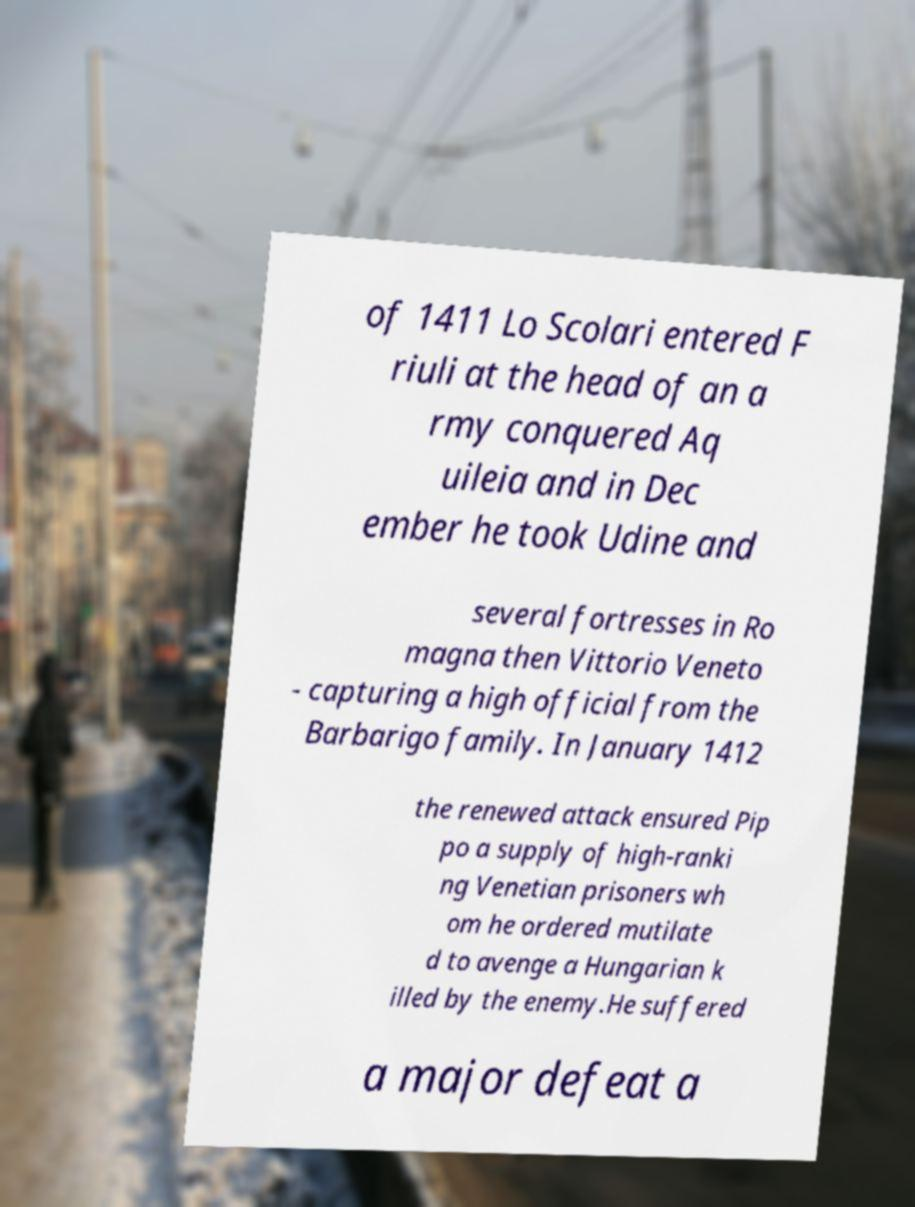Can you accurately transcribe the text from the provided image for me? of 1411 Lo Scolari entered F riuli at the head of an a rmy conquered Aq uileia and in Dec ember he took Udine and several fortresses in Ro magna then Vittorio Veneto - capturing a high official from the Barbarigo family. In January 1412 the renewed attack ensured Pip po a supply of high-ranki ng Venetian prisoners wh om he ordered mutilate d to avenge a Hungarian k illed by the enemy.He suffered a major defeat a 